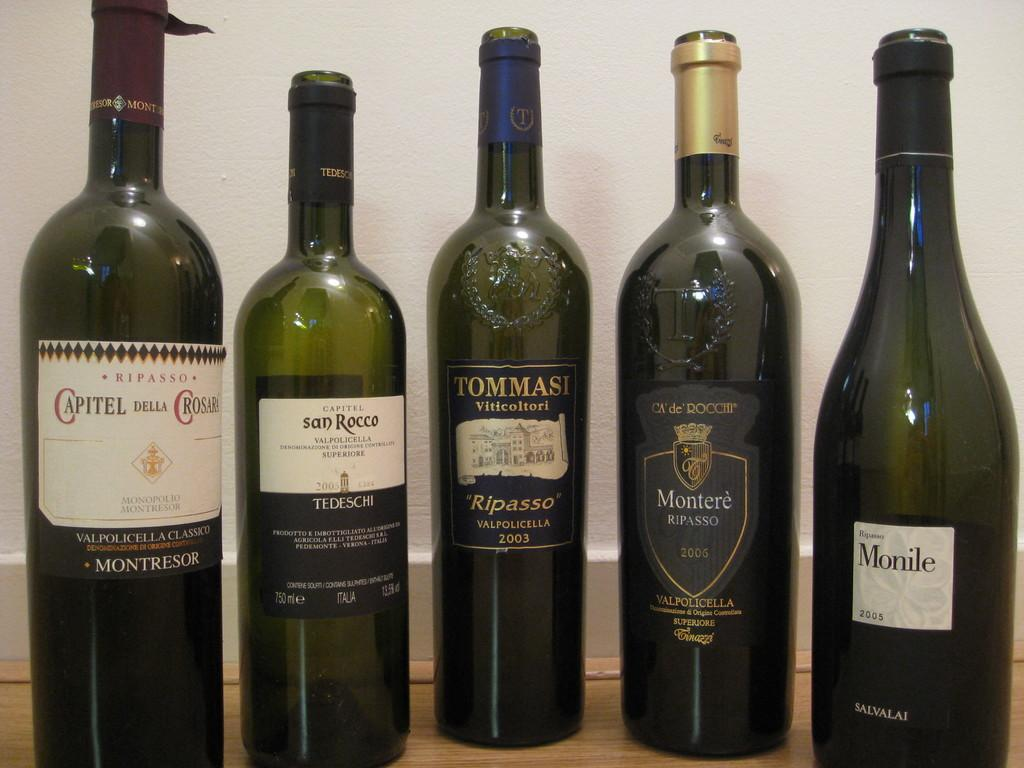<image>
Summarize the visual content of the image. A bottle dated 2003 has more bottles on either side. 